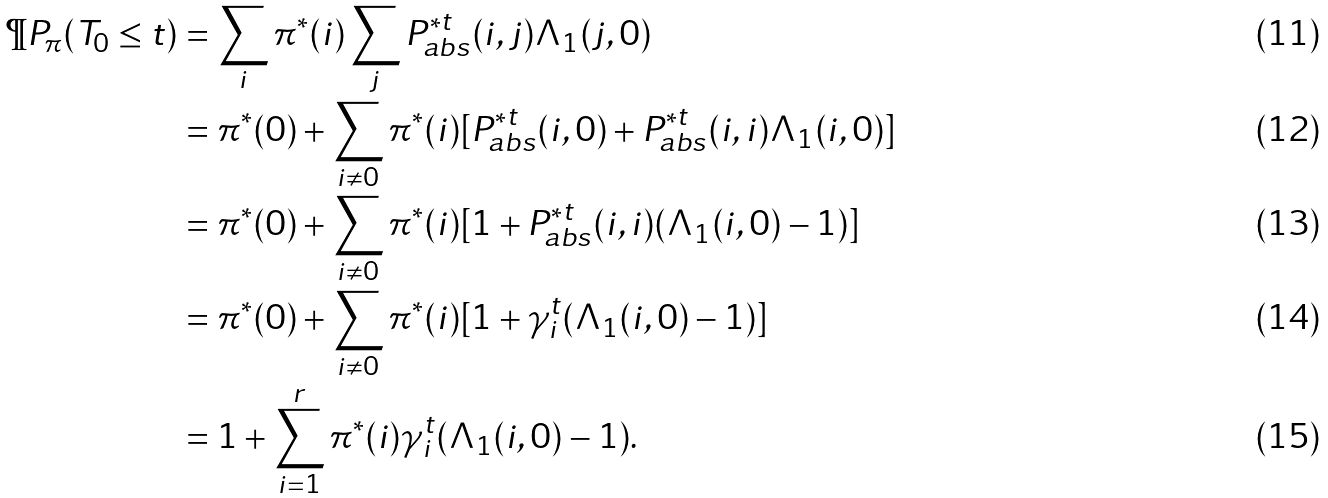<formula> <loc_0><loc_0><loc_500><loc_500>\P P _ { \pi } ( T _ { 0 } \leq t ) & = \sum _ { i } \pi ^ { * } ( i ) \sum _ { j } P _ { a b s } ^ { * t } ( i , j ) \Lambda _ { 1 } ( j , 0 ) \\ & = \pi ^ { * } ( 0 ) + \sum _ { i \neq 0 } \pi ^ { * } ( i ) [ P _ { a b s } ^ { * t } ( i , 0 ) + P _ { a b s } ^ { * t } ( i , i ) \Lambda _ { 1 } ( i , 0 ) ] \\ & = \pi ^ { * } ( 0 ) + \sum _ { i \neq 0 } \pi ^ { * } ( i ) [ 1 + P _ { a b s } ^ { * t } ( i , i ) ( \Lambda _ { 1 } ( i , 0 ) - 1 ) ] \\ & = \pi ^ { * } ( 0 ) + \sum _ { i \neq 0 } \pi ^ { * } ( i ) [ 1 + \gamma _ { i } ^ { t } ( \Lambda _ { 1 } ( i , 0 ) - 1 ) ] \\ & = 1 + \sum _ { i = 1 } ^ { r } \pi ^ { * } ( i ) \gamma _ { i } ^ { t } ( \Lambda _ { 1 } ( i , 0 ) - 1 ) .</formula> 